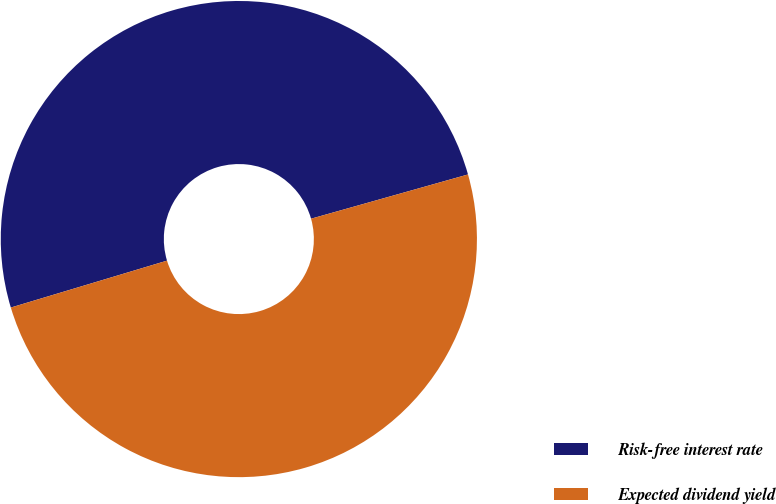<chart> <loc_0><loc_0><loc_500><loc_500><pie_chart><fcel>Risk-free interest rate<fcel>Expected dividend yield<nl><fcel>50.27%<fcel>49.73%<nl></chart> 